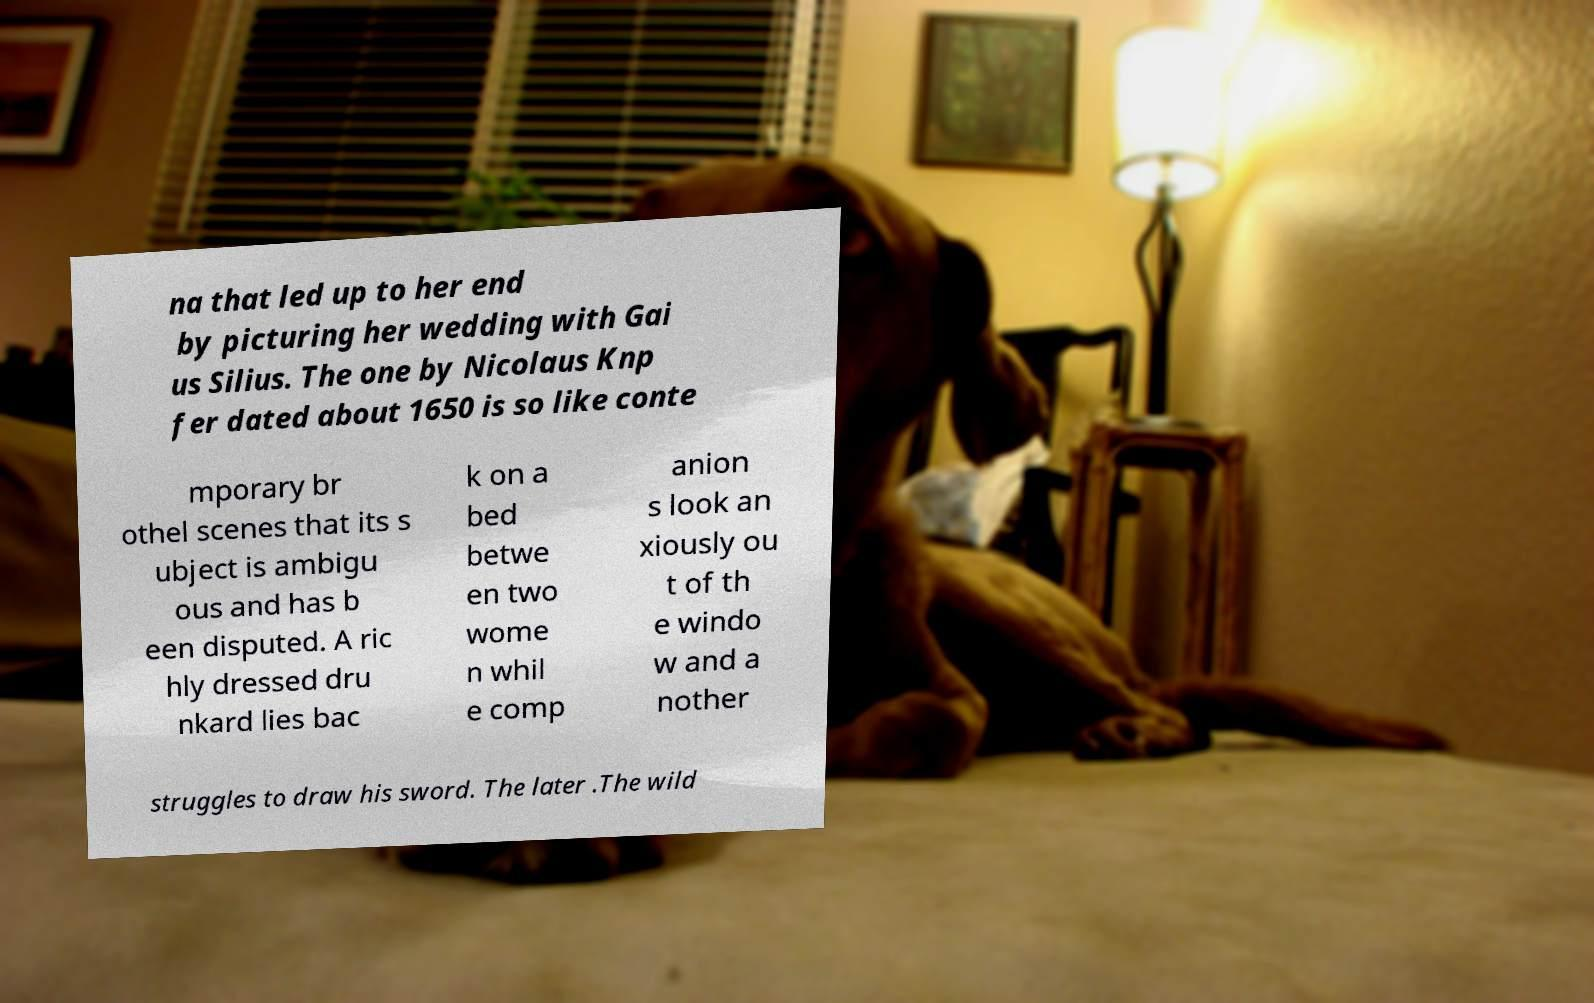Could you extract and type out the text from this image? na that led up to her end by picturing her wedding with Gai us Silius. The one by Nicolaus Knp fer dated about 1650 is so like conte mporary br othel scenes that its s ubject is ambigu ous and has b een disputed. A ric hly dressed dru nkard lies bac k on a bed betwe en two wome n whil e comp anion s look an xiously ou t of th e windo w and a nother struggles to draw his sword. The later .The wild 